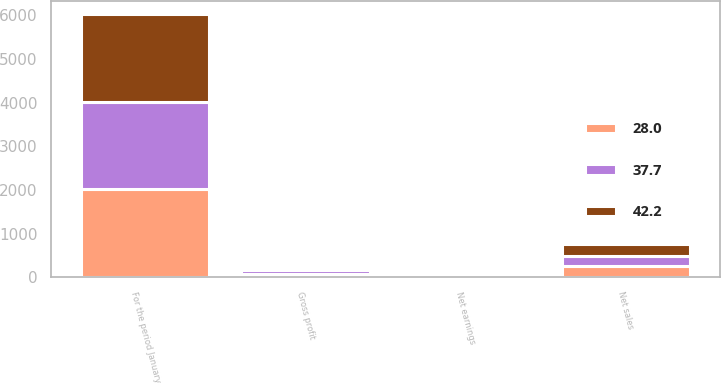Convert chart. <chart><loc_0><loc_0><loc_500><loc_500><stacked_bar_chart><ecel><fcel>For the period January<fcel>Net sales<fcel>Gross profit<fcel>Net earnings<nl><fcel>42.2<fcel>2013<fcel>255.2<fcel>84.1<fcel>37.7<nl><fcel>28<fcel>2012<fcel>249<fcel>86.4<fcel>42.2<nl><fcel>37.7<fcel>2011<fcel>247.4<fcel>73.1<fcel>28<nl></chart> 